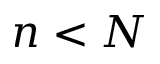<formula> <loc_0><loc_0><loc_500><loc_500>n < N</formula> 